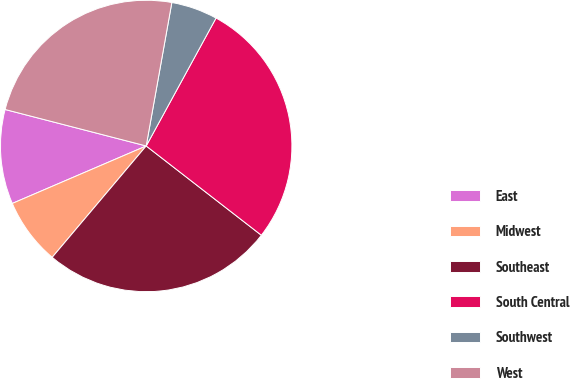<chart> <loc_0><loc_0><loc_500><loc_500><pie_chart><fcel>East<fcel>Midwest<fcel>Southeast<fcel>South Central<fcel>Southwest<fcel>West<nl><fcel>10.48%<fcel>7.39%<fcel>25.66%<fcel>27.54%<fcel>5.14%<fcel>23.79%<nl></chart> 